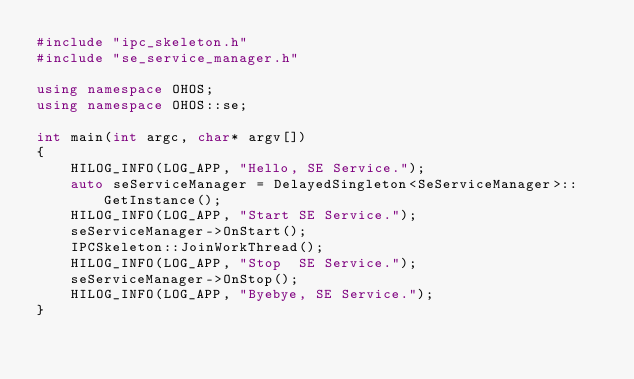<code> <loc_0><loc_0><loc_500><loc_500><_C++_>#include "ipc_skeleton.h"
#include "se_service_manager.h"

using namespace OHOS;
using namespace OHOS::se;

int main(int argc, char* argv[])
{
    HILOG_INFO(LOG_APP, "Hello, SE Service.");
    auto seServiceManager = DelayedSingleton<SeServiceManager>::GetInstance();
    HILOG_INFO(LOG_APP, "Start SE Service.");
    seServiceManager->OnStart();
    IPCSkeleton::JoinWorkThread();
    HILOG_INFO(LOG_APP, "Stop  SE Service.");
    seServiceManager->OnStop();
    HILOG_INFO(LOG_APP, "Byebye, SE Service.");
}</code> 